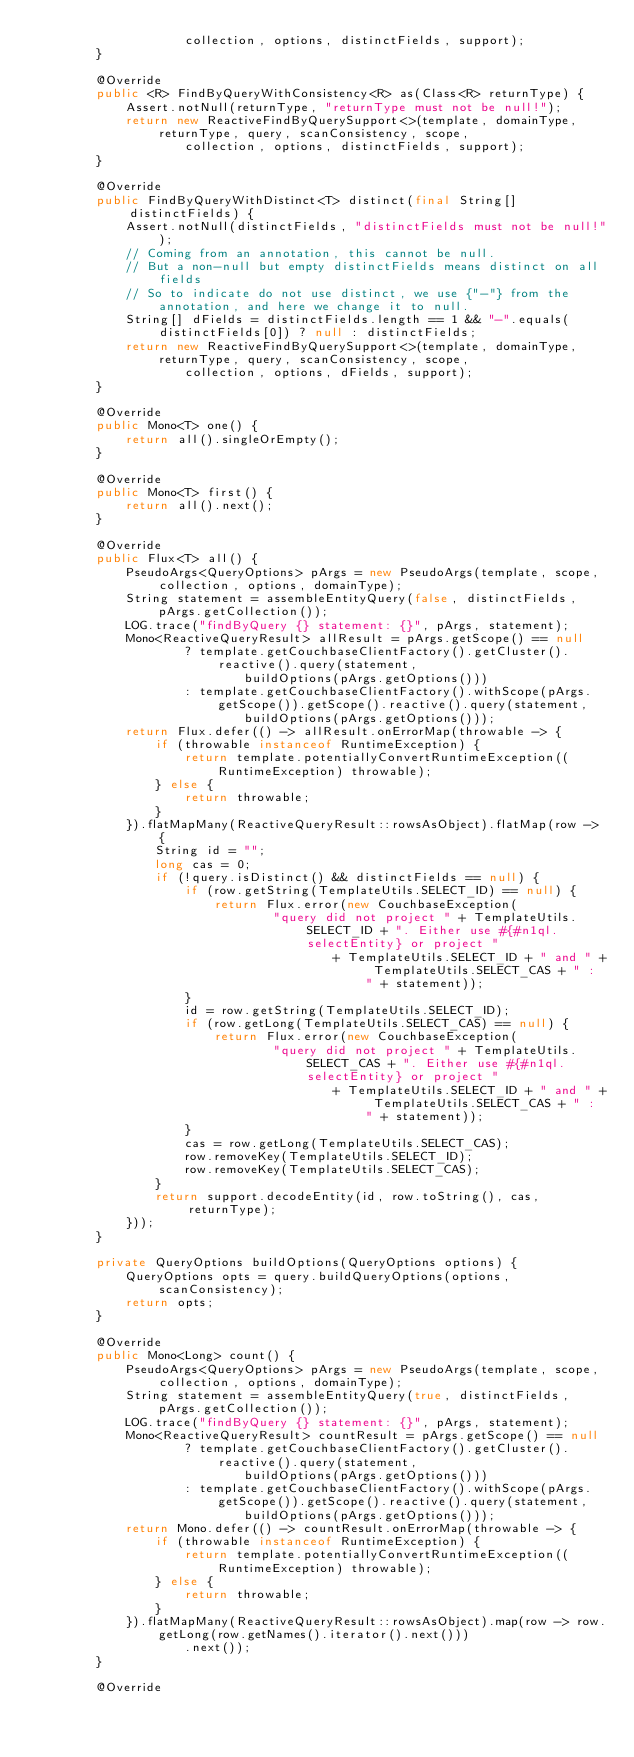<code> <loc_0><loc_0><loc_500><loc_500><_Java_>					collection, options, distinctFields, support);
		}

		@Override
		public <R> FindByQueryWithConsistency<R> as(Class<R> returnType) {
			Assert.notNull(returnType, "returnType must not be null!");
			return new ReactiveFindByQuerySupport<>(template, domainType, returnType, query, scanConsistency, scope,
					collection, options, distinctFields, support);
		}

		@Override
		public FindByQueryWithDistinct<T> distinct(final String[] distinctFields) {
			Assert.notNull(distinctFields, "distinctFields must not be null!");
			// Coming from an annotation, this cannot be null.
			// But a non-null but empty distinctFields means distinct on all fields
			// So to indicate do not use distinct, we use {"-"} from the annotation, and here we change it to null.
			String[] dFields = distinctFields.length == 1 && "-".equals(distinctFields[0]) ? null : distinctFields;
			return new ReactiveFindByQuerySupport<>(template, domainType, returnType, query, scanConsistency, scope,
					collection, options, dFields, support);
		}

		@Override
		public Mono<T> one() {
			return all().singleOrEmpty();
		}

		@Override
		public Mono<T> first() {
			return all().next();
		}

		@Override
		public Flux<T> all() {
			PseudoArgs<QueryOptions> pArgs = new PseudoArgs(template, scope, collection, options, domainType);
			String statement = assembleEntityQuery(false, distinctFields, pArgs.getCollection());
			LOG.trace("findByQuery {} statement: {}", pArgs, statement);
			Mono<ReactiveQueryResult> allResult = pArgs.getScope() == null
					? template.getCouchbaseClientFactory().getCluster().reactive().query(statement,
							buildOptions(pArgs.getOptions()))
					: template.getCouchbaseClientFactory().withScope(pArgs.getScope()).getScope().reactive().query(statement,
							buildOptions(pArgs.getOptions()));
			return Flux.defer(() -> allResult.onErrorMap(throwable -> {
				if (throwable instanceof RuntimeException) {
					return template.potentiallyConvertRuntimeException((RuntimeException) throwable);
				} else {
					return throwable;
				}
			}).flatMapMany(ReactiveQueryResult::rowsAsObject).flatMap(row -> {
				String id = "";
				long cas = 0;
				if (!query.isDistinct() && distinctFields == null) {
					if (row.getString(TemplateUtils.SELECT_ID) == null) {
						return Flux.error(new CouchbaseException(
								"query did not project " + TemplateUtils.SELECT_ID + ". Either use #{#n1ql.selectEntity} or project "
										+ TemplateUtils.SELECT_ID + " and " + TemplateUtils.SELECT_CAS + " : " + statement));
					}
					id = row.getString(TemplateUtils.SELECT_ID);
					if (row.getLong(TemplateUtils.SELECT_CAS) == null) {
						return Flux.error(new CouchbaseException(
								"query did not project " + TemplateUtils.SELECT_CAS + ". Either use #{#n1ql.selectEntity} or project "
										+ TemplateUtils.SELECT_ID + " and " + TemplateUtils.SELECT_CAS + " : " + statement));
					}
					cas = row.getLong(TemplateUtils.SELECT_CAS);
					row.removeKey(TemplateUtils.SELECT_ID);
					row.removeKey(TemplateUtils.SELECT_CAS);
				}
				return support.decodeEntity(id, row.toString(), cas, returnType);
			}));
		}

		private QueryOptions buildOptions(QueryOptions options) {
			QueryOptions opts = query.buildQueryOptions(options, scanConsistency);
			return opts;
		}

		@Override
		public Mono<Long> count() {
			PseudoArgs<QueryOptions> pArgs = new PseudoArgs(template, scope, collection, options, domainType);
			String statement = assembleEntityQuery(true, distinctFields, pArgs.getCollection());
			LOG.trace("findByQuery {} statement: {}", pArgs, statement);
			Mono<ReactiveQueryResult> countResult = pArgs.getScope() == null
					? template.getCouchbaseClientFactory().getCluster().reactive().query(statement,
							buildOptions(pArgs.getOptions()))
					: template.getCouchbaseClientFactory().withScope(pArgs.getScope()).getScope().reactive().query(statement,
							buildOptions(pArgs.getOptions()));
			return Mono.defer(() -> countResult.onErrorMap(throwable -> {
				if (throwable instanceof RuntimeException) {
					return template.potentiallyConvertRuntimeException((RuntimeException) throwable);
				} else {
					return throwable;
				}
			}).flatMapMany(ReactiveQueryResult::rowsAsObject).map(row -> row.getLong(row.getNames().iterator().next()))
					.next());
		}

		@Override</code> 